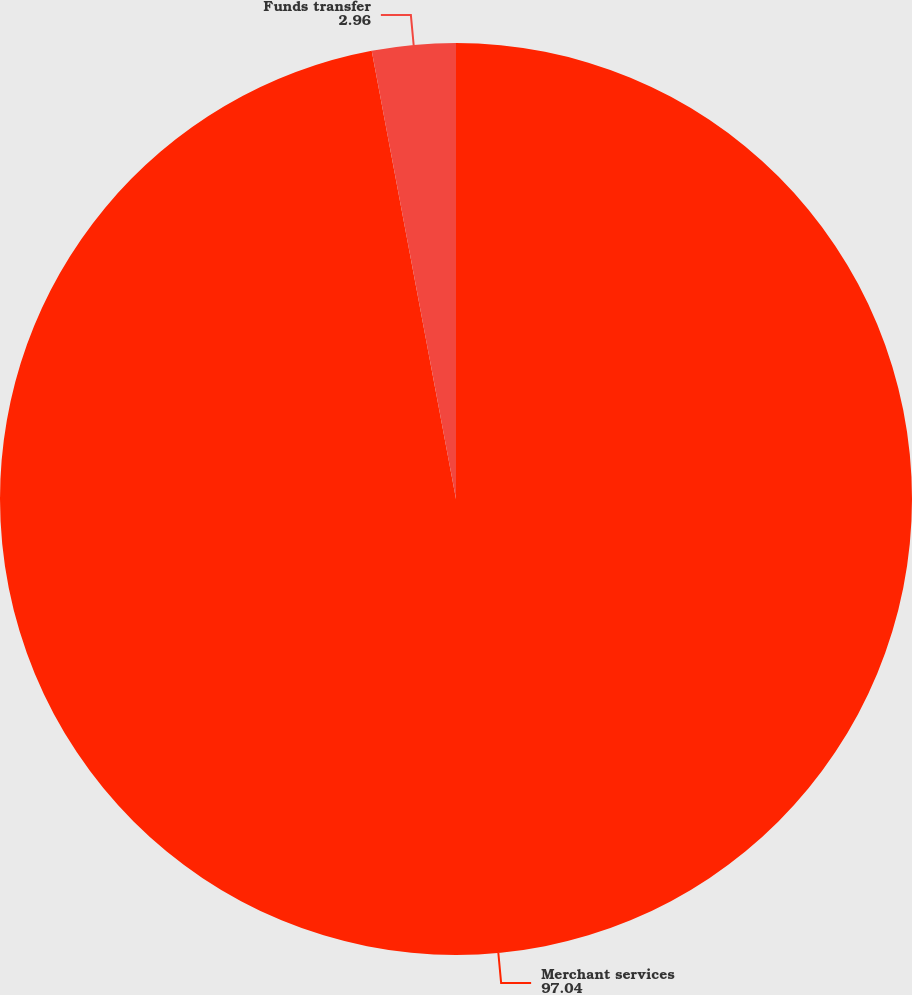Convert chart. <chart><loc_0><loc_0><loc_500><loc_500><pie_chart><fcel>Merchant services<fcel>Funds transfer<nl><fcel>97.04%<fcel>2.96%<nl></chart> 